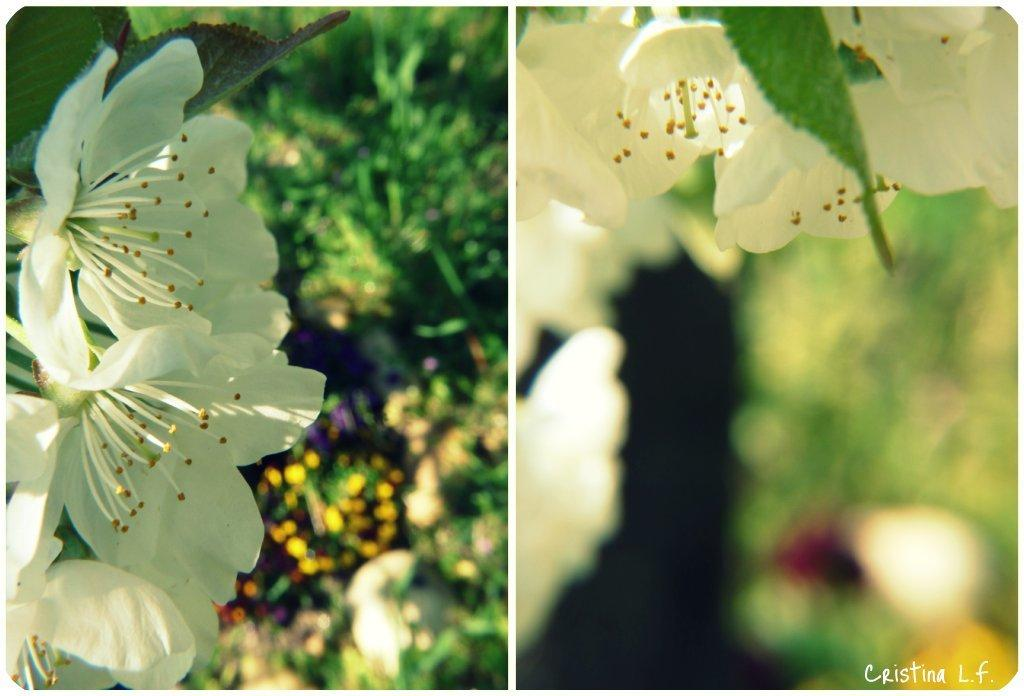What type of artwork is the image? The image is a collage. How many pictures are included in the collage? There are two pictures in the collage. Can you describe any specific elements in one of the pictures? In one of the pictures, there are flowers in the bottom right corner. Is there any text present in the collage? Yes, there is some text in one of the pictures. What is the name of the zephyr in the image? There is no zephyr present in the image. What type of baseball equipment can be seen in the image? There is no baseball equipment present in the image. 